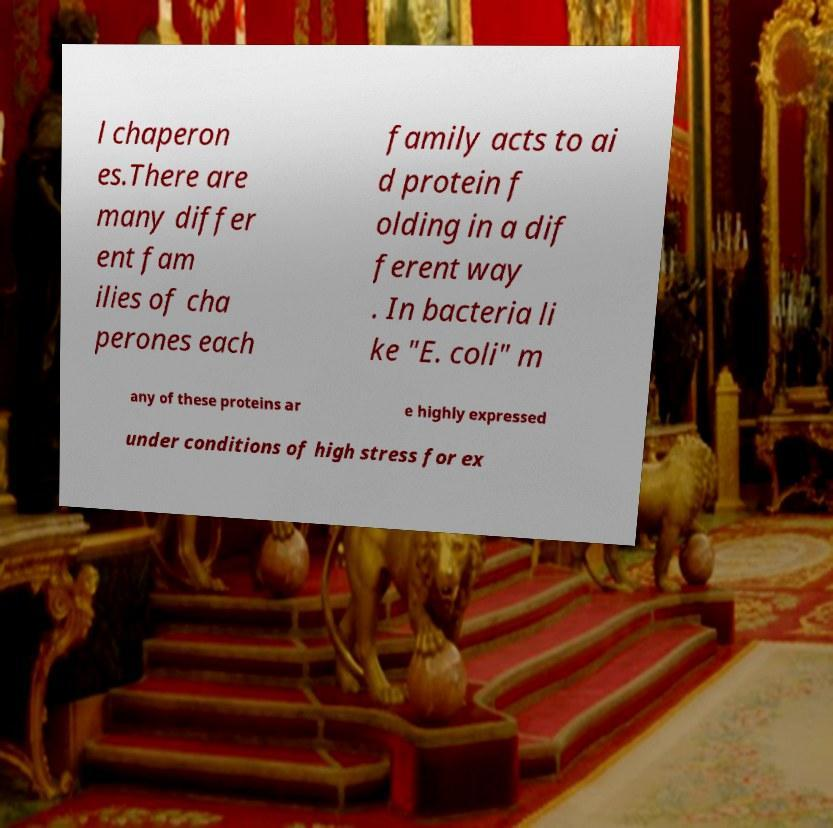Can you read and provide the text displayed in the image?This photo seems to have some interesting text. Can you extract and type it out for me? l chaperon es.There are many differ ent fam ilies of cha perones each family acts to ai d protein f olding in a dif ferent way . In bacteria li ke "E. coli" m any of these proteins ar e highly expressed under conditions of high stress for ex 